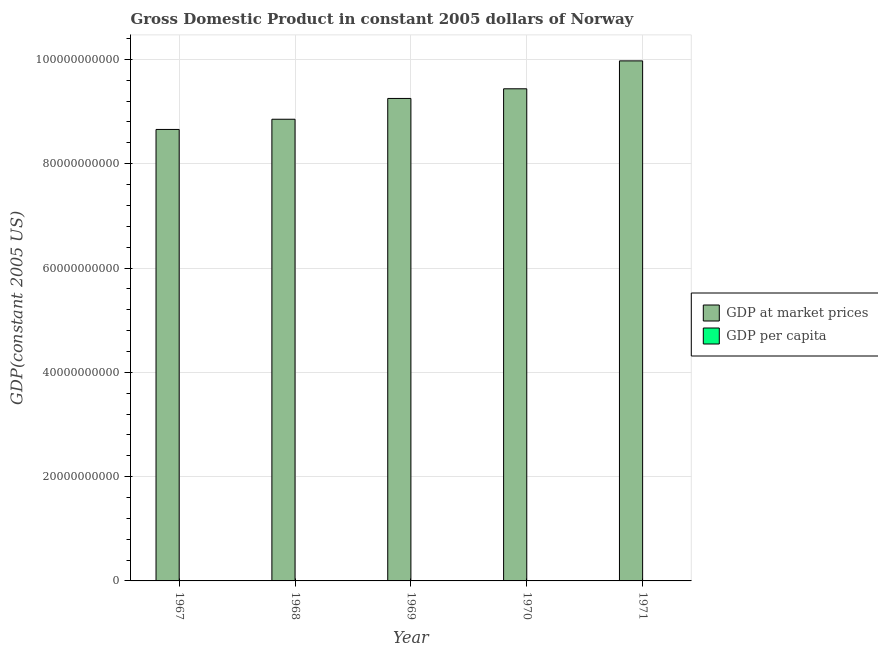How many different coloured bars are there?
Ensure brevity in your answer.  2. Are the number of bars per tick equal to the number of legend labels?
Make the answer very short. Yes. Are the number of bars on each tick of the X-axis equal?
Provide a short and direct response. Yes. What is the label of the 4th group of bars from the left?
Provide a succinct answer. 1970. What is the gdp per capita in 1969?
Offer a terse response. 2.40e+04. Across all years, what is the maximum gdp at market prices?
Keep it short and to the point. 9.97e+1. Across all years, what is the minimum gdp at market prices?
Ensure brevity in your answer.  8.66e+1. In which year was the gdp at market prices maximum?
Provide a succinct answer. 1971. In which year was the gdp at market prices minimum?
Offer a very short reply. 1967. What is the total gdp at market prices in the graph?
Offer a very short reply. 4.62e+11. What is the difference between the gdp per capita in 1968 and that in 1971?
Offer a very short reply. -2353.18. What is the difference between the gdp per capita in 1968 and the gdp at market prices in 1970?
Make the answer very short. -1151.87. What is the average gdp at market prices per year?
Your answer should be very brief. 9.23e+1. In how many years, is the gdp per capita greater than 40000000000 US$?
Keep it short and to the point. 0. What is the ratio of the gdp per capita in 1967 to that in 1968?
Your answer should be compact. 0.99. Is the difference between the gdp at market prices in 1967 and 1971 greater than the difference between the gdp per capita in 1967 and 1971?
Ensure brevity in your answer.  No. What is the difference between the highest and the second highest gdp per capita?
Ensure brevity in your answer.  1201.31. What is the difference between the highest and the lowest gdp at market prices?
Provide a short and direct response. 1.31e+1. Is the sum of the gdp at market prices in 1968 and 1971 greater than the maximum gdp per capita across all years?
Provide a succinct answer. Yes. What does the 1st bar from the left in 1967 represents?
Provide a succinct answer. GDP at market prices. What does the 2nd bar from the right in 1967 represents?
Keep it short and to the point. GDP at market prices. Are the values on the major ticks of Y-axis written in scientific E-notation?
Your answer should be compact. No. Where does the legend appear in the graph?
Make the answer very short. Center right. How many legend labels are there?
Offer a terse response. 2. What is the title of the graph?
Your answer should be compact. Gross Domestic Product in constant 2005 dollars of Norway. Does "Male population" appear as one of the legend labels in the graph?
Offer a very short reply. No. What is the label or title of the Y-axis?
Offer a terse response. GDP(constant 2005 US). What is the GDP(constant 2005 US) of GDP at market prices in 1967?
Your answer should be very brief. 8.66e+1. What is the GDP(constant 2005 US) of GDP per capita in 1967?
Keep it short and to the point. 2.29e+04. What is the GDP(constant 2005 US) in GDP at market prices in 1968?
Provide a short and direct response. 8.85e+1. What is the GDP(constant 2005 US) in GDP per capita in 1968?
Offer a terse response. 2.32e+04. What is the GDP(constant 2005 US) in GDP at market prices in 1969?
Your answer should be very brief. 9.25e+1. What is the GDP(constant 2005 US) in GDP per capita in 1969?
Provide a succinct answer. 2.40e+04. What is the GDP(constant 2005 US) in GDP at market prices in 1970?
Your answer should be very brief. 9.44e+1. What is the GDP(constant 2005 US) in GDP per capita in 1970?
Provide a succinct answer. 2.43e+04. What is the GDP(constant 2005 US) of GDP at market prices in 1971?
Your response must be concise. 9.97e+1. What is the GDP(constant 2005 US) in GDP per capita in 1971?
Give a very brief answer. 2.55e+04. Across all years, what is the maximum GDP(constant 2005 US) of GDP at market prices?
Give a very brief answer. 9.97e+1. Across all years, what is the maximum GDP(constant 2005 US) in GDP per capita?
Your response must be concise. 2.55e+04. Across all years, what is the minimum GDP(constant 2005 US) in GDP at market prices?
Provide a succinct answer. 8.66e+1. Across all years, what is the minimum GDP(constant 2005 US) in GDP per capita?
Provide a short and direct response. 2.29e+04. What is the total GDP(constant 2005 US) of GDP at market prices in the graph?
Offer a terse response. 4.62e+11. What is the total GDP(constant 2005 US) in GDP per capita in the graph?
Your response must be concise. 1.20e+05. What is the difference between the GDP(constant 2005 US) in GDP at market prices in 1967 and that in 1968?
Your answer should be compact. -1.96e+09. What is the difference between the GDP(constant 2005 US) of GDP per capita in 1967 and that in 1968?
Offer a very short reply. -321.14. What is the difference between the GDP(constant 2005 US) in GDP at market prices in 1967 and that in 1969?
Ensure brevity in your answer.  -5.94e+09. What is the difference between the GDP(constant 2005 US) in GDP per capita in 1967 and that in 1969?
Provide a short and direct response. -1169.33. What is the difference between the GDP(constant 2005 US) of GDP at market prices in 1967 and that in 1970?
Your response must be concise. -7.80e+09. What is the difference between the GDP(constant 2005 US) in GDP per capita in 1967 and that in 1970?
Provide a succinct answer. -1473. What is the difference between the GDP(constant 2005 US) in GDP at market prices in 1967 and that in 1971?
Provide a succinct answer. -1.31e+1. What is the difference between the GDP(constant 2005 US) of GDP per capita in 1967 and that in 1971?
Your answer should be very brief. -2674.32. What is the difference between the GDP(constant 2005 US) in GDP at market prices in 1968 and that in 1969?
Your response must be concise. -3.99e+09. What is the difference between the GDP(constant 2005 US) in GDP per capita in 1968 and that in 1969?
Offer a terse response. -848.19. What is the difference between the GDP(constant 2005 US) of GDP at market prices in 1968 and that in 1970?
Your answer should be compact. -5.84e+09. What is the difference between the GDP(constant 2005 US) of GDP per capita in 1968 and that in 1970?
Give a very brief answer. -1151.87. What is the difference between the GDP(constant 2005 US) in GDP at market prices in 1968 and that in 1971?
Ensure brevity in your answer.  -1.12e+1. What is the difference between the GDP(constant 2005 US) of GDP per capita in 1968 and that in 1971?
Offer a very short reply. -2353.18. What is the difference between the GDP(constant 2005 US) in GDP at market prices in 1969 and that in 1970?
Give a very brief answer. -1.85e+09. What is the difference between the GDP(constant 2005 US) in GDP per capita in 1969 and that in 1970?
Your response must be concise. -303.67. What is the difference between the GDP(constant 2005 US) in GDP at market prices in 1969 and that in 1971?
Provide a succinct answer. -7.20e+09. What is the difference between the GDP(constant 2005 US) of GDP per capita in 1969 and that in 1971?
Your answer should be compact. -1504.99. What is the difference between the GDP(constant 2005 US) in GDP at market prices in 1970 and that in 1971?
Offer a very short reply. -5.35e+09. What is the difference between the GDP(constant 2005 US) in GDP per capita in 1970 and that in 1971?
Provide a succinct answer. -1201.32. What is the difference between the GDP(constant 2005 US) in GDP at market prices in 1967 and the GDP(constant 2005 US) in GDP per capita in 1968?
Your response must be concise. 8.66e+1. What is the difference between the GDP(constant 2005 US) in GDP at market prices in 1967 and the GDP(constant 2005 US) in GDP per capita in 1969?
Your answer should be compact. 8.66e+1. What is the difference between the GDP(constant 2005 US) of GDP at market prices in 1967 and the GDP(constant 2005 US) of GDP per capita in 1970?
Provide a short and direct response. 8.66e+1. What is the difference between the GDP(constant 2005 US) in GDP at market prices in 1967 and the GDP(constant 2005 US) in GDP per capita in 1971?
Provide a short and direct response. 8.66e+1. What is the difference between the GDP(constant 2005 US) in GDP at market prices in 1968 and the GDP(constant 2005 US) in GDP per capita in 1969?
Offer a terse response. 8.85e+1. What is the difference between the GDP(constant 2005 US) in GDP at market prices in 1968 and the GDP(constant 2005 US) in GDP per capita in 1970?
Your answer should be compact. 8.85e+1. What is the difference between the GDP(constant 2005 US) in GDP at market prices in 1968 and the GDP(constant 2005 US) in GDP per capita in 1971?
Make the answer very short. 8.85e+1. What is the difference between the GDP(constant 2005 US) of GDP at market prices in 1969 and the GDP(constant 2005 US) of GDP per capita in 1970?
Keep it short and to the point. 9.25e+1. What is the difference between the GDP(constant 2005 US) of GDP at market prices in 1969 and the GDP(constant 2005 US) of GDP per capita in 1971?
Provide a short and direct response. 9.25e+1. What is the difference between the GDP(constant 2005 US) in GDP at market prices in 1970 and the GDP(constant 2005 US) in GDP per capita in 1971?
Provide a short and direct response. 9.44e+1. What is the average GDP(constant 2005 US) in GDP at market prices per year?
Offer a terse response. 9.23e+1. What is the average GDP(constant 2005 US) of GDP per capita per year?
Offer a terse response. 2.40e+04. In the year 1967, what is the difference between the GDP(constant 2005 US) of GDP at market prices and GDP(constant 2005 US) of GDP per capita?
Your answer should be compact. 8.66e+1. In the year 1968, what is the difference between the GDP(constant 2005 US) in GDP at market prices and GDP(constant 2005 US) in GDP per capita?
Give a very brief answer. 8.85e+1. In the year 1969, what is the difference between the GDP(constant 2005 US) of GDP at market prices and GDP(constant 2005 US) of GDP per capita?
Offer a very short reply. 9.25e+1. In the year 1970, what is the difference between the GDP(constant 2005 US) in GDP at market prices and GDP(constant 2005 US) in GDP per capita?
Provide a succinct answer. 9.44e+1. In the year 1971, what is the difference between the GDP(constant 2005 US) in GDP at market prices and GDP(constant 2005 US) in GDP per capita?
Your answer should be compact. 9.97e+1. What is the ratio of the GDP(constant 2005 US) of GDP at market prices in 1967 to that in 1968?
Your answer should be compact. 0.98. What is the ratio of the GDP(constant 2005 US) of GDP per capita in 1967 to that in 1968?
Offer a terse response. 0.99. What is the ratio of the GDP(constant 2005 US) of GDP at market prices in 1967 to that in 1969?
Your answer should be very brief. 0.94. What is the ratio of the GDP(constant 2005 US) of GDP per capita in 1967 to that in 1969?
Offer a very short reply. 0.95. What is the ratio of the GDP(constant 2005 US) of GDP at market prices in 1967 to that in 1970?
Your response must be concise. 0.92. What is the ratio of the GDP(constant 2005 US) of GDP per capita in 1967 to that in 1970?
Keep it short and to the point. 0.94. What is the ratio of the GDP(constant 2005 US) in GDP at market prices in 1967 to that in 1971?
Provide a succinct answer. 0.87. What is the ratio of the GDP(constant 2005 US) of GDP per capita in 1967 to that in 1971?
Offer a very short reply. 0.9. What is the ratio of the GDP(constant 2005 US) of GDP at market prices in 1968 to that in 1969?
Keep it short and to the point. 0.96. What is the ratio of the GDP(constant 2005 US) in GDP per capita in 1968 to that in 1969?
Offer a very short reply. 0.96. What is the ratio of the GDP(constant 2005 US) of GDP at market prices in 1968 to that in 1970?
Your response must be concise. 0.94. What is the ratio of the GDP(constant 2005 US) of GDP per capita in 1968 to that in 1970?
Keep it short and to the point. 0.95. What is the ratio of the GDP(constant 2005 US) of GDP at market prices in 1968 to that in 1971?
Ensure brevity in your answer.  0.89. What is the ratio of the GDP(constant 2005 US) in GDP per capita in 1968 to that in 1971?
Your answer should be compact. 0.91. What is the ratio of the GDP(constant 2005 US) in GDP at market prices in 1969 to that in 1970?
Offer a terse response. 0.98. What is the ratio of the GDP(constant 2005 US) of GDP per capita in 1969 to that in 1970?
Your answer should be very brief. 0.99. What is the ratio of the GDP(constant 2005 US) of GDP at market prices in 1969 to that in 1971?
Keep it short and to the point. 0.93. What is the ratio of the GDP(constant 2005 US) of GDP per capita in 1969 to that in 1971?
Your answer should be very brief. 0.94. What is the ratio of the GDP(constant 2005 US) of GDP at market prices in 1970 to that in 1971?
Give a very brief answer. 0.95. What is the ratio of the GDP(constant 2005 US) in GDP per capita in 1970 to that in 1971?
Provide a succinct answer. 0.95. What is the difference between the highest and the second highest GDP(constant 2005 US) of GDP at market prices?
Ensure brevity in your answer.  5.35e+09. What is the difference between the highest and the second highest GDP(constant 2005 US) of GDP per capita?
Ensure brevity in your answer.  1201.32. What is the difference between the highest and the lowest GDP(constant 2005 US) in GDP at market prices?
Offer a terse response. 1.31e+1. What is the difference between the highest and the lowest GDP(constant 2005 US) of GDP per capita?
Ensure brevity in your answer.  2674.32. 